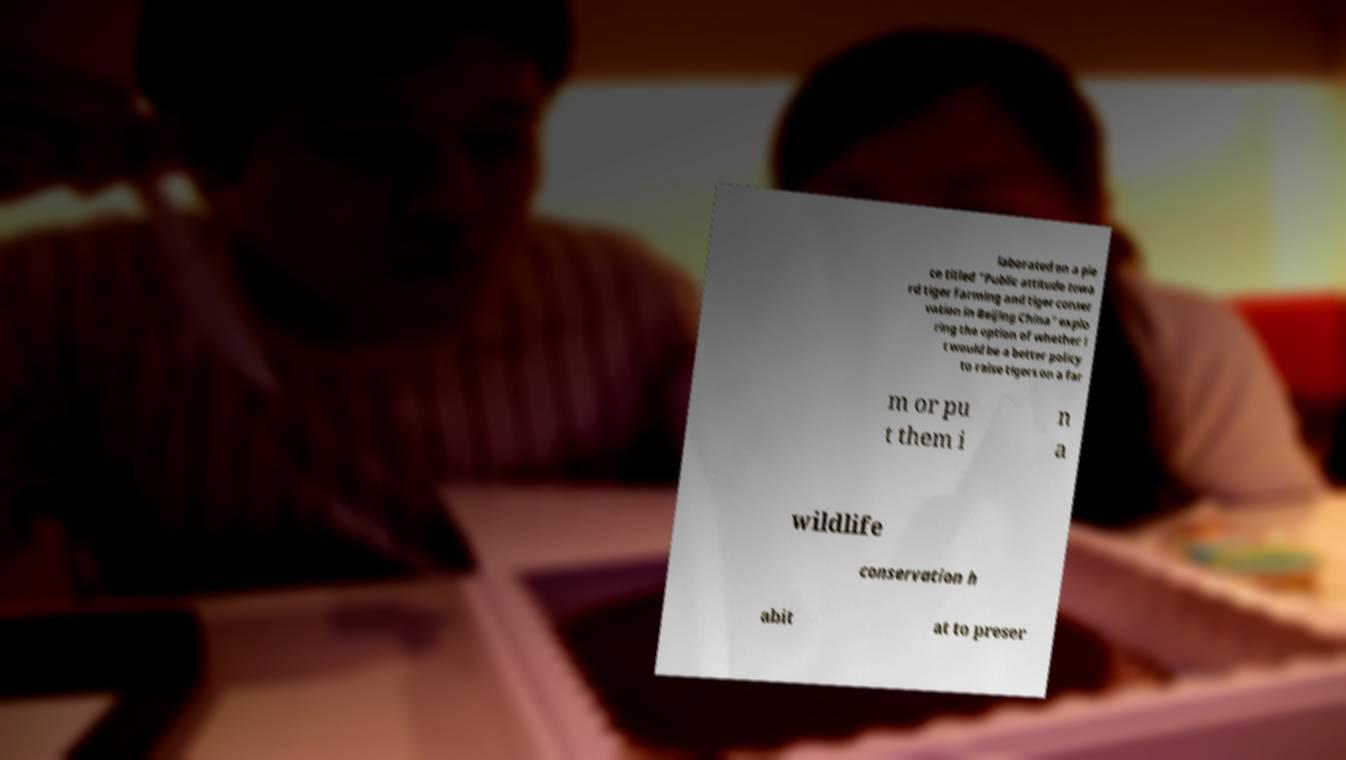Please identify and transcribe the text found in this image. laborated on a pie ce titled "Public attitude towa rd tiger farming and tiger conser vation in Beijing China" explo ring the option of whether i t would be a better policy to raise tigers on a far m or pu t them i n a wildlife conservation h abit at to preser 